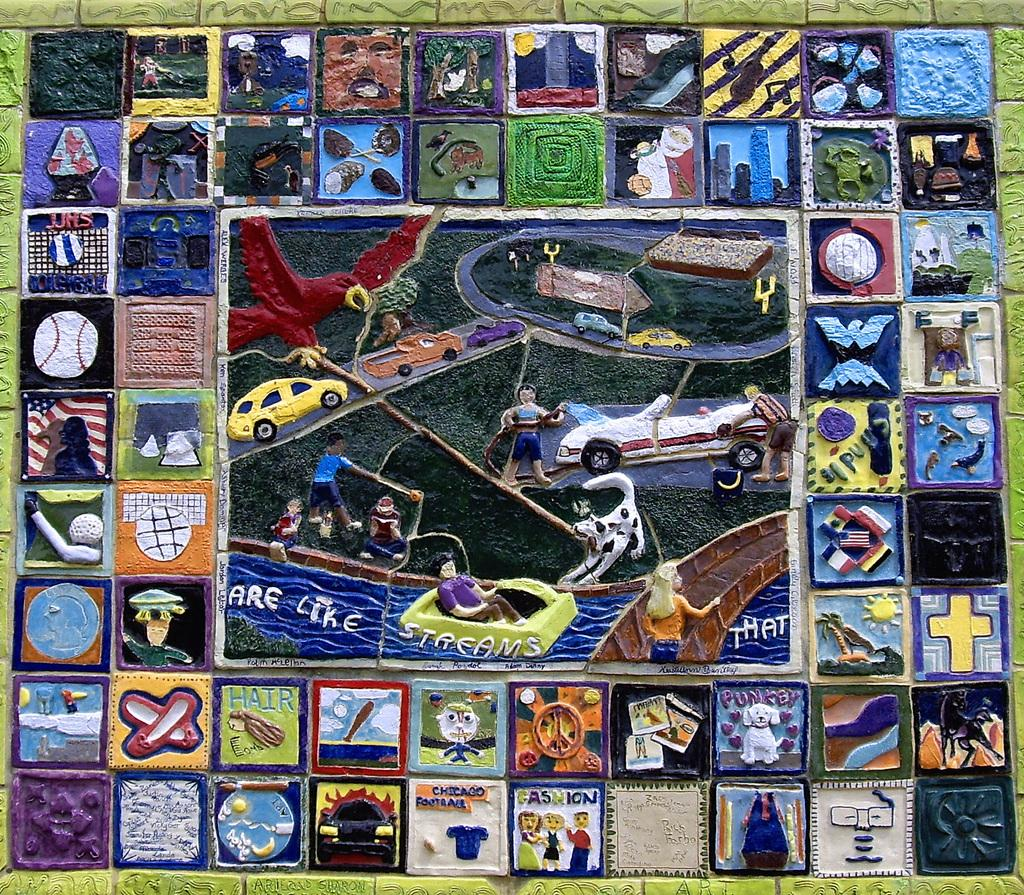What is displayed on the platform in the image? There are paintings on a platform in the image. What else can be seen in the image besides the paintings? There are vehicles, persons, objects, and texts in the image. How much salt is visible on the pot in the image? There is no pot or salt present in the image. What type of recess can be seen in the image? There is no recess present in the image. 